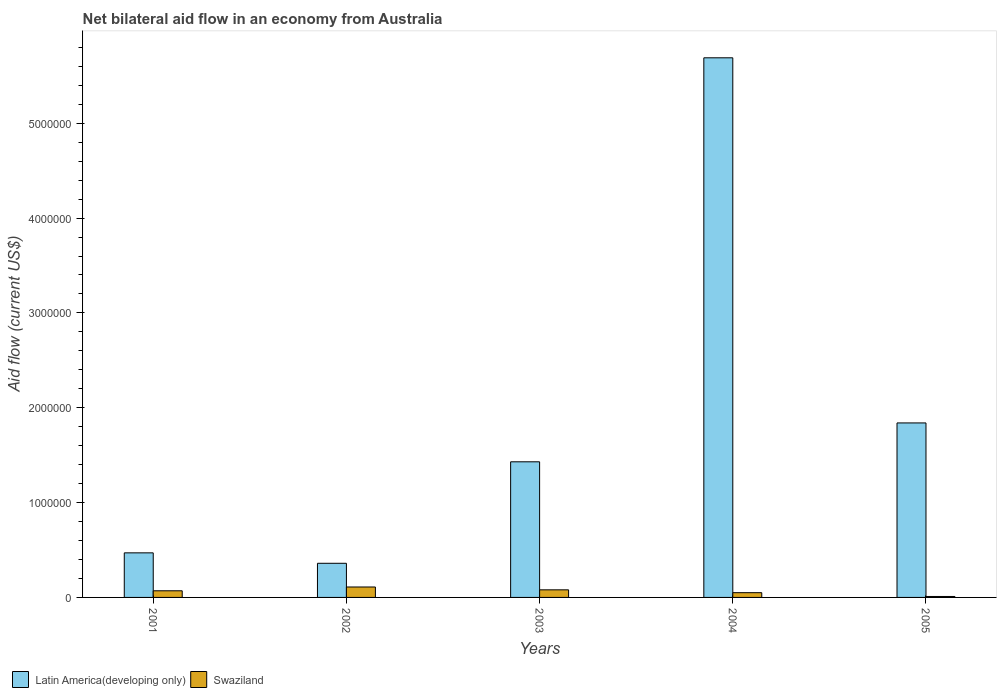How many different coloured bars are there?
Give a very brief answer. 2. How many groups of bars are there?
Offer a very short reply. 5. Are the number of bars per tick equal to the number of legend labels?
Your answer should be very brief. Yes. What is the net bilateral aid flow in Latin America(developing only) in 2001?
Offer a terse response. 4.70e+05. Across all years, what is the maximum net bilateral aid flow in Latin America(developing only)?
Your response must be concise. 5.69e+06. Across all years, what is the minimum net bilateral aid flow in Latin America(developing only)?
Offer a terse response. 3.60e+05. What is the difference between the net bilateral aid flow in Swaziland in 2001 and the net bilateral aid flow in Latin America(developing only) in 2002?
Offer a terse response. -2.90e+05. What is the average net bilateral aid flow in Latin America(developing only) per year?
Offer a terse response. 1.96e+06. In the year 2004, what is the difference between the net bilateral aid flow in Swaziland and net bilateral aid flow in Latin America(developing only)?
Ensure brevity in your answer.  -5.64e+06. What is the ratio of the net bilateral aid flow in Latin America(developing only) in 2001 to that in 2005?
Give a very brief answer. 0.26. What is the difference between the highest and the second highest net bilateral aid flow in Swaziland?
Your answer should be very brief. 3.00e+04. What is the difference between the highest and the lowest net bilateral aid flow in Swaziland?
Provide a short and direct response. 1.00e+05. In how many years, is the net bilateral aid flow in Latin America(developing only) greater than the average net bilateral aid flow in Latin America(developing only) taken over all years?
Keep it short and to the point. 1. What does the 2nd bar from the left in 2003 represents?
Provide a short and direct response. Swaziland. What does the 1st bar from the right in 2003 represents?
Keep it short and to the point. Swaziland. How many bars are there?
Offer a very short reply. 10. How many years are there in the graph?
Give a very brief answer. 5. What is the difference between two consecutive major ticks on the Y-axis?
Give a very brief answer. 1.00e+06. Are the values on the major ticks of Y-axis written in scientific E-notation?
Provide a short and direct response. No. How many legend labels are there?
Provide a succinct answer. 2. What is the title of the graph?
Keep it short and to the point. Net bilateral aid flow in an economy from Australia. Does "Greece" appear as one of the legend labels in the graph?
Provide a short and direct response. No. What is the label or title of the X-axis?
Make the answer very short. Years. What is the Aid flow (current US$) in Swaziland in 2002?
Your answer should be very brief. 1.10e+05. What is the Aid flow (current US$) of Latin America(developing only) in 2003?
Your response must be concise. 1.43e+06. What is the Aid flow (current US$) in Swaziland in 2003?
Offer a terse response. 8.00e+04. What is the Aid flow (current US$) of Latin America(developing only) in 2004?
Provide a short and direct response. 5.69e+06. What is the Aid flow (current US$) of Latin America(developing only) in 2005?
Make the answer very short. 1.84e+06. What is the Aid flow (current US$) of Swaziland in 2005?
Offer a very short reply. 10000. Across all years, what is the maximum Aid flow (current US$) in Latin America(developing only)?
Give a very brief answer. 5.69e+06. Across all years, what is the maximum Aid flow (current US$) in Swaziland?
Provide a succinct answer. 1.10e+05. What is the total Aid flow (current US$) in Latin America(developing only) in the graph?
Your answer should be very brief. 9.79e+06. What is the difference between the Aid flow (current US$) of Latin America(developing only) in 2001 and that in 2003?
Make the answer very short. -9.60e+05. What is the difference between the Aid flow (current US$) in Latin America(developing only) in 2001 and that in 2004?
Provide a succinct answer. -5.22e+06. What is the difference between the Aid flow (current US$) of Swaziland in 2001 and that in 2004?
Make the answer very short. 2.00e+04. What is the difference between the Aid flow (current US$) in Latin America(developing only) in 2001 and that in 2005?
Offer a very short reply. -1.37e+06. What is the difference between the Aid flow (current US$) in Swaziland in 2001 and that in 2005?
Provide a short and direct response. 6.00e+04. What is the difference between the Aid flow (current US$) of Latin America(developing only) in 2002 and that in 2003?
Your answer should be compact. -1.07e+06. What is the difference between the Aid flow (current US$) of Latin America(developing only) in 2002 and that in 2004?
Provide a succinct answer. -5.33e+06. What is the difference between the Aid flow (current US$) of Latin America(developing only) in 2002 and that in 2005?
Provide a short and direct response. -1.48e+06. What is the difference between the Aid flow (current US$) of Swaziland in 2002 and that in 2005?
Offer a terse response. 1.00e+05. What is the difference between the Aid flow (current US$) in Latin America(developing only) in 2003 and that in 2004?
Offer a very short reply. -4.26e+06. What is the difference between the Aid flow (current US$) in Latin America(developing only) in 2003 and that in 2005?
Ensure brevity in your answer.  -4.10e+05. What is the difference between the Aid flow (current US$) of Swaziland in 2003 and that in 2005?
Provide a short and direct response. 7.00e+04. What is the difference between the Aid flow (current US$) of Latin America(developing only) in 2004 and that in 2005?
Provide a short and direct response. 3.85e+06. What is the difference between the Aid flow (current US$) in Swaziland in 2004 and that in 2005?
Make the answer very short. 4.00e+04. What is the difference between the Aid flow (current US$) of Latin America(developing only) in 2001 and the Aid flow (current US$) of Swaziland in 2002?
Your answer should be very brief. 3.60e+05. What is the difference between the Aid flow (current US$) of Latin America(developing only) in 2001 and the Aid flow (current US$) of Swaziland in 2003?
Keep it short and to the point. 3.90e+05. What is the difference between the Aid flow (current US$) in Latin America(developing only) in 2002 and the Aid flow (current US$) in Swaziland in 2003?
Give a very brief answer. 2.80e+05. What is the difference between the Aid flow (current US$) of Latin America(developing only) in 2003 and the Aid flow (current US$) of Swaziland in 2004?
Keep it short and to the point. 1.38e+06. What is the difference between the Aid flow (current US$) in Latin America(developing only) in 2003 and the Aid flow (current US$) in Swaziland in 2005?
Make the answer very short. 1.42e+06. What is the difference between the Aid flow (current US$) of Latin America(developing only) in 2004 and the Aid flow (current US$) of Swaziland in 2005?
Provide a short and direct response. 5.68e+06. What is the average Aid flow (current US$) in Latin America(developing only) per year?
Your answer should be very brief. 1.96e+06. What is the average Aid flow (current US$) of Swaziland per year?
Your answer should be compact. 6.40e+04. In the year 2001, what is the difference between the Aid flow (current US$) in Latin America(developing only) and Aid flow (current US$) in Swaziland?
Your answer should be very brief. 4.00e+05. In the year 2003, what is the difference between the Aid flow (current US$) in Latin America(developing only) and Aid flow (current US$) in Swaziland?
Offer a terse response. 1.35e+06. In the year 2004, what is the difference between the Aid flow (current US$) of Latin America(developing only) and Aid flow (current US$) of Swaziland?
Keep it short and to the point. 5.64e+06. In the year 2005, what is the difference between the Aid flow (current US$) of Latin America(developing only) and Aid flow (current US$) of Swaziland?
Your answer should be compact. 1.83e+06. What is the ratio of the Aid flow (current US$) in Latin America(developing only) in 2001 to that in 2002?
Keep it short and to the point. 1.31. What is the ratio of the Aid flow (current US$) of Swaziland in 2001 to that in 2002?
Keep it short and to the point. 0.64. What is the ratio of the Aid flow (current US$) in Latin America(developing only) in 2001 to that in 2003?
Ensure brevity in your answer.  0.33. What is the ratio of the Aid flow (current US$) in Swaziland in 2001 to that in 2003?
Provide a succinct answer. 0.88. What is the ratio of the Aid flow (current US$) in Latin America(developing only) in 2001 to that in 2004?
Your response must be concise. 0.08. What is the ratio of the Aid flow (current US$) in Latin America(developing only) in 2001 to that in 2005?
Ensure brevity in your answer.  0.26. What is the ratio of the Aid flow (current US$) of Latin America(developing only) in 2002 to that in 2003?
Offer a terse response. 0.25. What is the ratio of the Aid flow (current US$) in Swaziland in 2002 to that in 2003?
Give a very brief answer. 1.38. What is the ratio of the Aid flow (current US$) of Latin America(developing only) in 2002 to that in 2004?
Give a very brief answer. 0.06. What is the ratio of the Aid flow (current US$) in Latin America(developing only) in 2002 to that in 2005?
Keep it short and to the point. 0.2. What is the ratio of the Aid flow (current US$) of Latin America(developing only) in 2003 to that in 2004?
Ensure brevity in your answer.  0.25. What is the ratio of the Aid flow (current US$) of Swaziland in 2003 to that in 2004?
Offer a terse response. 1.6. What is the ratio of the Aid flow (current US$) in Latin America(developing only) in 2003 to that in 2005?
Offer a very short reply. 0.78. What is the ratio of the Aid flow (current US$) of Swaziland in 2003 to that in 2005?
Give a very brief answer. 8. What is the ratio of the Aid flow (current US$) of Latin America(developing only) in 2004 to that in 2005?
Make the answer very short. 3.09. What is the difference between the highest and the second highest Aid flow (current US$) in Latin America(developing only)?
Ensure brevity in your answer.  3.85e+06. What is the difference between the highest and the second highest Aid flow (current US$) of Swaziland?
Provide a short and direct response. 3.00e+04. What is the difference between the highest and the lowest Aid flow (current US$) in Latin America(developing only)?
Offer a very short reply. 5.33e+06. What is the difference between the highest and the lowest Aid flow (current US$) in Swaziland?
Offer a very short reply. 1.00e+05. 